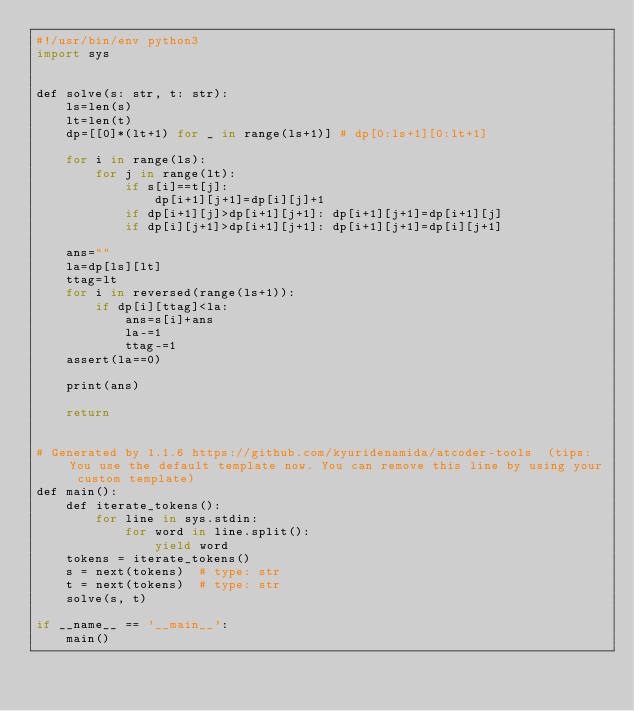Convert code to text. <code><loc_0><loc_0><loc_500><loc_500><_Nim_>#!/usr/bin/env python3
import sys


def solve(s: str, t: str):
    ls=len(s)
    lt=len(t)
    dp=[[0]*(lt+1) for _ in range(ls+1)] # dp[0:ls+1][0:lt+1]

    for i in range(ls):
        for j in range(lt):
            if s[i]==t[j]:
                dp[i+1][j+1]=dp[i][j]+1
            if dp[i+1][j]>dp[i+1][j+1]: dp[i+1][j+1]=dp[i+1][j]
            if dp[i][j+1]>dp[i+1][j+1]: dp[i+1][j+1]=dp[i][j+1]

    ans=""
    la=dp[ls][lt]
    ttag=lt
    for i in reversed(range(ls+1)):
        if dp[i][ttag]<la:
            ans=s[i]+ans
            la-=1
            ttag-=1
    assert(la==0)
    
    print(ans)

    return


# Generated by 1.1.6 https://github.com/kyuridenamida/atcoder-tools  (tips: You use the default template now. You can remove this line by using your custom template)
def main():
    def iterate_tokens():
        for line in sys.stdin:
            for word in line.split():
                yield word
    tokens = iterate_tokens()
    s = next(tokens)  # type: str
    t = next(tokens)  # type: str
    solve(s, t)

if __name__ == '__main__':
    main()
</code> 